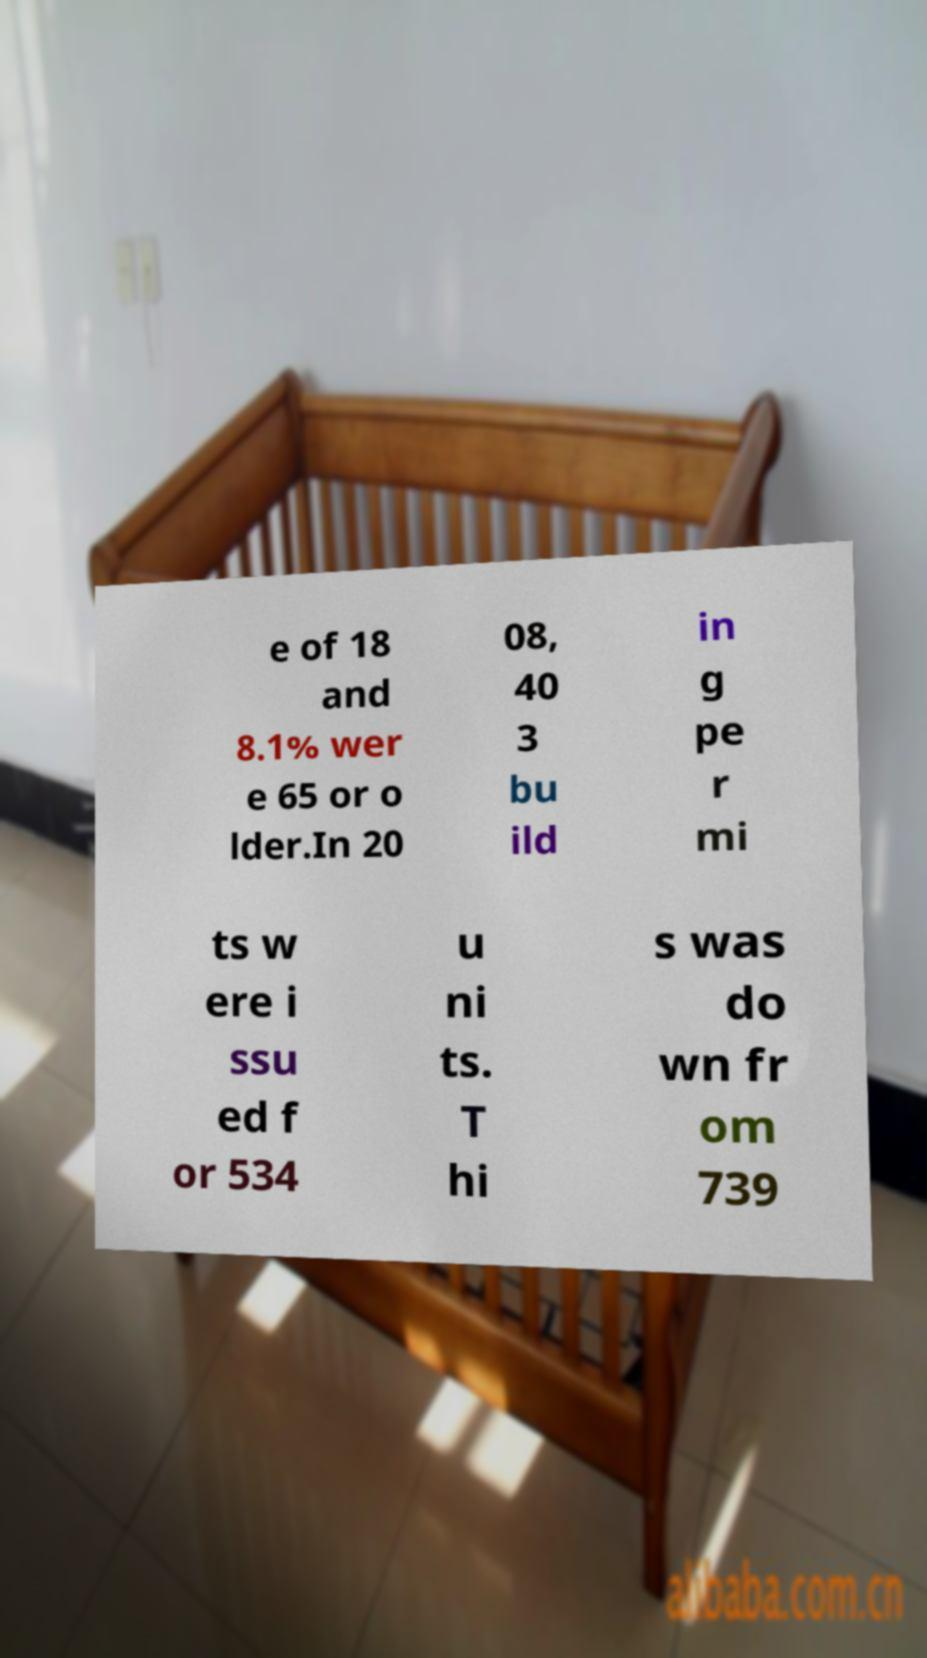Could you assist in decoding the text presented in this image and type it out clearly? e of 18 and 8.1% wer e 65 or o lder.In 20 08, 40 3 bu ild in g pe r mi ts w ere i ssu ed f or 534 u ni ts. T hi s was do wn fr om 739 